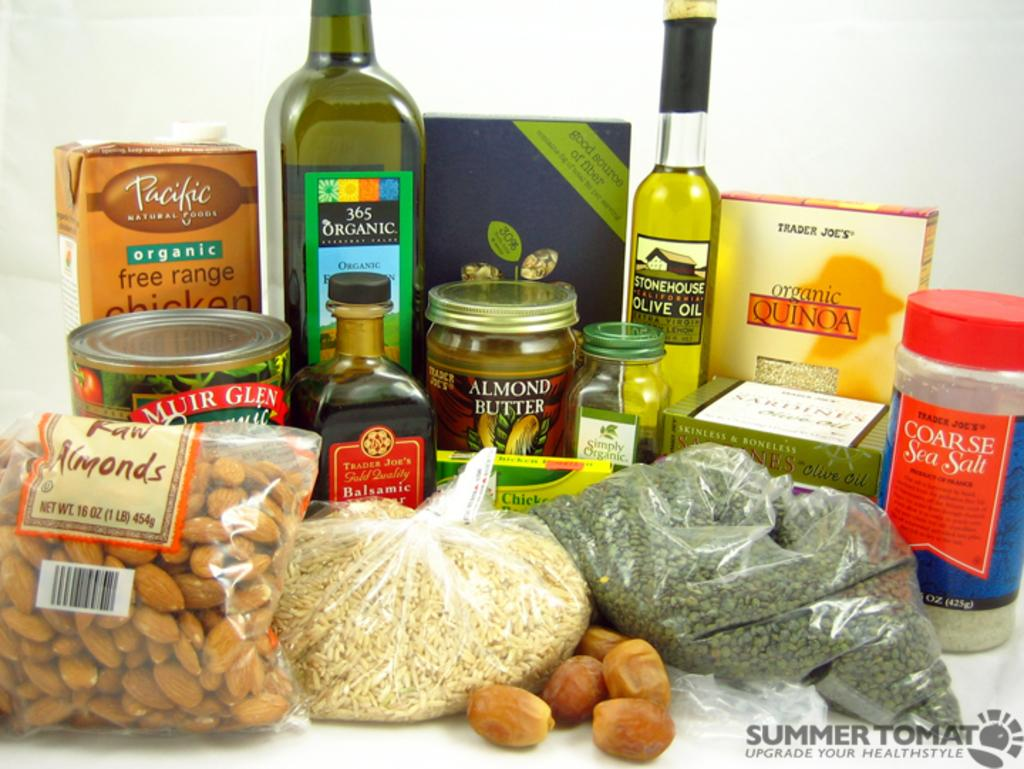What type of food item is in the packet in the image? There is an almond packet in the image. What other food items can be seen in the image? There is rice, coarse sea salt, and olive oil in the image. What type of spread is in the bottle in the image? There is an almond butter bottle in the image. What type of bottle is also present in the image? There is an organic bottle in the image. How many other bottles can be seen in the image? There are other bottles in the image. How does the air circulate through the hole in the image? There is no hole present in the image; it is a collection of food items and bottles. 